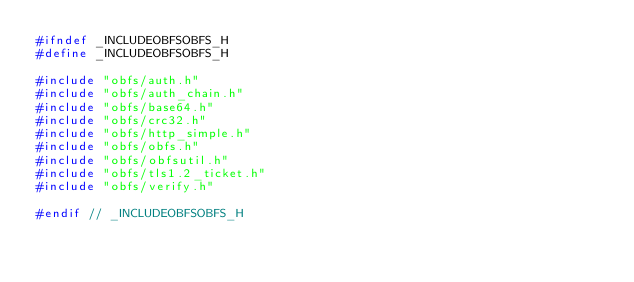<code> <loc_0><loc_0><loc_500><loc_500><_C_>#ifndef _INCLUDEOBFSOBFS_H
#define _INCLUDEOBFSOBFS_H

#include "obfs/auth.h"
#include "obfs/auth_chain.h"
#include "obfs/base64.h"
#include "obfs/crc32.h"
#include "obfs/http_simple.h"
#include "obfs/obfs.h"
#include "obfs/obfsutil.h"
#include "obfs/tls1.2_ticket.h"
#include "obfs/verify.h"

#endif // _INCLUDEOBFSOBFS_H
</code> 